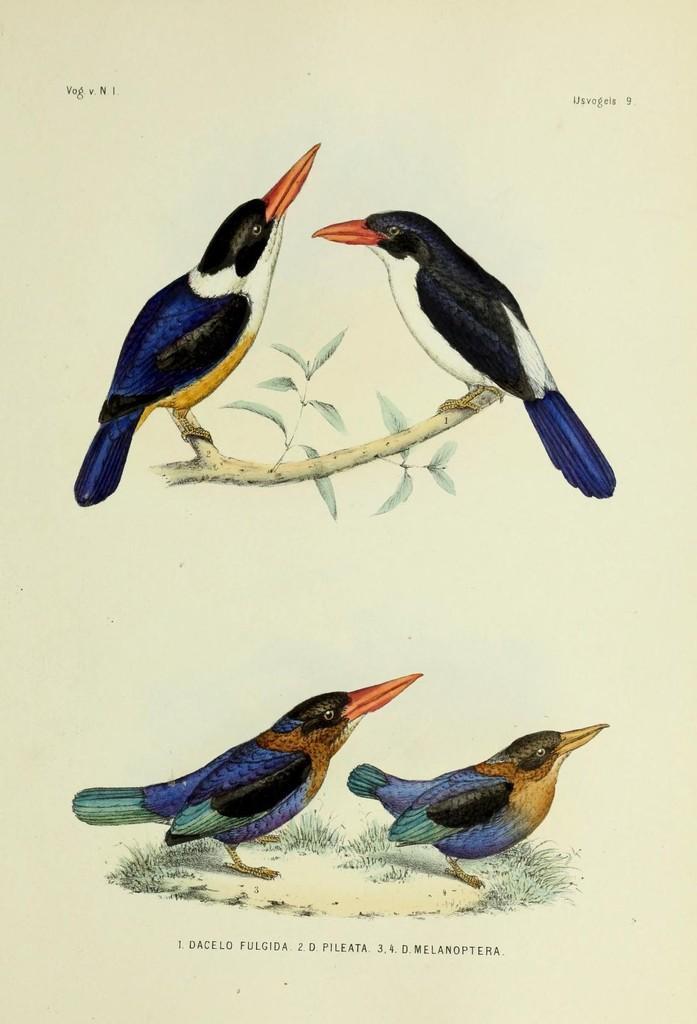Describe this image in one or two sentences. In this image we can see picture of birds on the back of tree and on the land. Bottom of the image some text is written. 